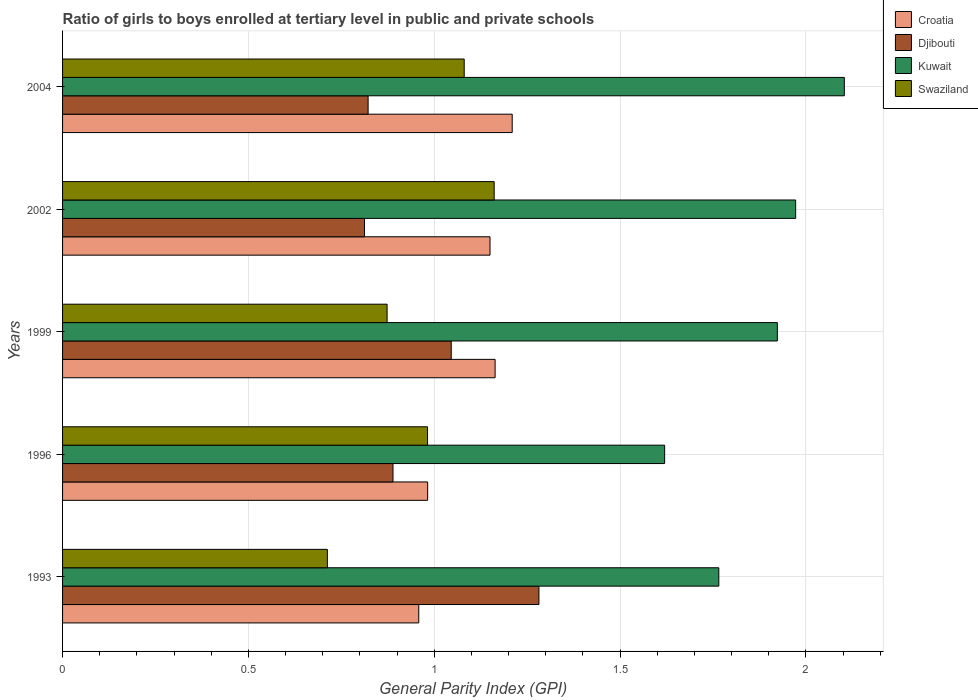Are the number of bars per tick equal to the number of legend labels?
Your answer should be compact. Yes. Are the number of bars on each tick of the Y-axis equal?
Your answer should be compact. Yes. What is the label of the 1st group of bars from the top?
Your answer should be very brief. 2004. What is the general parity index in Swaziland in 2002?
Ensure brevity in your answer.  1.16. Across all years, what is the maximum general parity index in Kuwait?
Give a very brief answer. 2.1. Across all years, what is the minimum general parity index in Croatia?
Offer a very short reply. 0.96. What is the total general parity index in Swaziland in the graph?
Provide a short and direct response. 4.81. What is the difference between the general parity index in Kuwait in 1999 and that in 2002?
Your response must be concise. -0.05. What is the difference between the general parity index in Djibouti in 1993 and the general parity index in Swaziland in 2002?
Make the answer very short. 0.12. What is the average general parity index in Djibouti per year?
Provide a short and direct response. 0.97. In the year 2002, what is the difference between the general parity index in Kuwait and general parity index in Swaziland?
Give a very brief answer. 0.81. In how many years, is the general parity index in Kuwait greater than 1.7 ?
Give a very brief answer. 4. What is the ratio of the general parity index in Kuwait in 1993 to that in 1996?
Provide a succinct answer. 1.09. What is the difference between the highest and the second highest general parity index in Djibouti?
Ensure brevity in your answer.  0.24. What is the difference between the highest and the lowest general parity index in Swaziland?
Make the answer very short. 0.45. Is the sum of the general parity index in Kuwait in 1993 and 1996 greater than the maximum general parity index in Djibouti across all years?
Keep it short and to the point. Yes. Is it the case that in every year, the sum of the general parity index in Croatia and general parity index in Kuwait is greater than the sum of general parity index in Swaziland and general parity index in Djibouti?
Give a very brief answer. Yes. What does the 4th bar from the top in 1996 represents?
Your answer should be very brief. Croatia. What does the 2nd bar from the bottom in 1993 represents?
Offer a very short reply. Djibouti. Are all the bars in the graph horizontal?
Make the answer very short. Yes. What is the difference between two consecutive major ticks on the X-axis?
Give a very brief answer. 0.5. Does the graph contain any zero values?
Offer a very short reply. No. How many legend labels are there?
Provide a succinct answer. 4. How are the legend labels stacked?
Offer a very short reply. Vertical. What is the title of the graph?
Your answer should be compact. Ratio of girls to boys enrolled at tertiary level in public and private schools. What is the label or title of the X-axis?
Your answer should be compact. General Parity Index (GPI). What is the General Parity Index (GPI) of Croatia in 1993?
Offer a very short reply. 0.96. What is the General Parity Index (GPI) in Djibouti in 1993?
Make the answer very short. 1.28. What is the General Parity Index (GPI) of Kuwait in 1993?
Ensure brevity in your answer.  1.77. What is the General Parity Index (GPI) of Swaziland in 1993?
Ensure brevity in your answer.  0.71. What is the General Parity Index (GPI) in Croatia in 1996?
Make the answer very short. 0.98. What is the General Parity Index (GPI) in Djibouti in 1996?
Make the answer very short. 0.89. What is the General Parity Index (GPI) of Kuwait in 1996?
Offer a very short reply. 1.62. What is the General Parity Index (GPI) of Swaziland in 1996?
Offer a terse response. 0.98. What is the General Parity Index (GPI) in Croatia in 1999?
Offer a very short reply. 1.16. What is the General Parity Index (GPI) of Djibouti in 1999?
Give a very brief answer. 1.05. What is the General Parity Index (GPI) in Kuwait in 1999?
Your response must be concise. 1.92. What is the General Parity Index (GPI) of Swaziland in 1999?
Your answer should be very brief. 0.87. What is the General Parity Index (GPI) in Croatia in 2002?
Your response must be concise. 1.15. What is the General Parity Index (GPI) in Djibouti in 2002?
Offer a very short reply. 0.81. What is the General Parity Index (GPI) in Kuwait in 2002?
Your response must be concise. 1.97. What is the General Parity Index (GPI) of Swaziland in 2002?
Ensure brevity in your answer.  1.16. What is the General Parity Index (GPI) in Croatia in 2004?
Offer a very short reply. 1.21. What is the General Parity Index (GPI) of Djibouti in 2004?
Make the answer very short. 0.82. What is the General Parity Index (GPI) in Kuwait in 2004?
Provide a short and direct response. 2.1. What is the General Parity Index (GPI) of Swaziland in 2004?
Make the answer very short. 1.08. Across all years, what is the maximum General Parity Index (GPI) of Croatia?
Your answer should be very brief. 1.21. Across all years, what is the maximum General Parity Index (GPI) in Djibouti?
Your answer should be very brief. 1.28. Across all years, what is the maximum General Parity Index (GPI) of Kuwait?
Your answer should be very brief. 2.1. Across all years, what is the maximum General Parity Index (GPI) of Swaziland?
Make the answer very short. 1.16. Across all years, what is the minimum General Parity Index (GPI) in Croatia?
Your answer should be very brief. 0.96. Across all years, what is the minimum General Parity Index (GPI) in Djibouti?
Your answer should be compact. 0.81. Across all years, what is the minimum General Parity Index (GPI) in Kuwait?
Your answer should be very brief. 1.62. Across all years, what is the minimum General Parity Index (GPI) in Swaziland?
Your answer should be very brief. 0.71. What is the total General Parity Index (GPI) of Croatia in the graph?
Make the answer very short. 5.46. What is the total General Parity Index (GPI) of Djibouti in the graph?
Keep it short and to the point. 4.85. What is the total General Parity Index (GPI) of Kuwait in the graph?
Your answer should be compact. 9.38. What is the total General Parity Index (GPI) of Swaziland in the graph?
Give a very brief answer. 4.81. What is the difference between the General Parity Index (GPI) of Croatia in 1993 and that in 1996?
Your answer should be compact. -0.02. What is the difference between the General Parity Index (GPI) in Djibouti in 1993 and that in 1996?
Ensure brevity in your answer.  0.39. What is the difference between the General Parity Index (GPI) of Kuwait in 1993 and that in 1996?
Provide a succinct answer. 0.15. What is the difference between the General Parity Index (GPI) of Swaziland in 1993 and that in 1996?
Ensure brevity in your answer.  -0.27. What is the difference between the General Parity Index (GPI) of Croatia in 1993 and that in 1999?
Keep it short and to the point. -0.21. What is the difference between the General Parity Index (GPI) of Djibouti in 1993 and that in 1999?
Give a very brief answer. 0.24. What is the difference between the General Parity Index (GPI) of Kuwait in 1993 and that in 1999?
Your answer should be very brief. -0.16. What is the difference between the General Parity Index (GPI) in Swaziland in 1993 and that in 1999?
Your answer should be very brief. -0.16. What is the difference between the General Parity Index (GPI) of Croatia in 1993 and that in 2002?
Provide a succinct answer. -0.19. What is the difference between the General Parity Index (GPI) in Djibouti in 1993 and that in 2002?
Ensure brevity in your answer.  0.47. What is the difference between the General Parity Index (GPI) in Kuwait in 1993 and that in 2002?
Provide a succinct answer. -0.21. What is the difference between the General Parity Index (GPI) in Swaziland in 1993 and that in 2002?
Provide a short and direct response. -0.45. What is the difference between the General Parity Index (GPI) of Croatia in 1993 and that in 2004?
Your answer should be compact. -0.25. What is the difference between the General Parity Index (GPI) of Djibouti in 1993 and that in 2004?
Your answer should be very brief. 0.46. What is the difference between the General Parity Index (GPI) in Kuwait in 1993 and that in 2004?
Make the answer very short. -0.34. What is the difference between the General Parity Index (GPI) of Swaziland in 1993 and that in 2004?
Make the answer very short. -0.37. What is the difference between the General Parity Index (GPI) of Croatia in 1996 and that in 1999?
Make the answer very short. -0.18. What is the difference between the General Parity Index (GPI) in Djibouti in 1996 and that in 1999?
Offer a very short reply. -0.16. What is the difference between the General Parity Index (GPI) of Kuwait in 1996 and that in 1999?
Your answer should be very brief. -0.3. What is the difference between the General Parity Index (GPI) of Swaziland in 1996 and that in 1999?
Offer a terse response. 0.11. What is the difference between the General Parity Index (GPI) in Croatia in 1996 and that in 2002?
Your answer should be compact. -0.17. What is the difference between the General Parity Index (GPI) in Djibouti in 1996 and that in 2002?
Your response must be concise. 0.08. What is the difference between the General Parity Index (GPI) in Kuwait in 1996 and that in 2002?
Offer a terse response. -0.35. What is the difference between the General Parity Index (GPI) in Swaziland in 1996 and that in 2002?
Your answer should be very brief. -0.18. What is the difference between the General Parity Index (GPI) of Croatia in 1996 and that in 2004?
Keep it short and to the point. -0.23. What is the difference between the General Parity Index (GPI) of Djibouti in 1996 and that in 2004?
Offer a very short reply. 0.07. What is the difference between the General Parity Index (GPI) in Kuwait in 1996 and that in 2004?
Keep it short and to the point. -0.48. What is the difference between the General Parity Index (GPI) in Swaziland in 1996 and that in 2004?
Provide a short and direct response. -0.1. What is the difference between the General Parity Index (GPI) of Croatia in 1999 and that in 2002?
Your answer should be compact. 0.01. What is the difference between the General Parity Index (GPI) in Djibouti in 1999 and that in 2002?
Provide a succinct answer. 0.23. What is the difference between the General Parity Index (GPI) of Kuwait in 1999 and that in 2002?
Your answer should be very brief. -0.05. What is the difference between the General Parity Index (GPI) in Swaziland in 1999 and that in 2002?
Provide a succinct answer. -0.29. What is the difference between the General Parity Index (GPI) in Croatia in 1999 and that in 2004?
Give a very brief answer. -0.05. What is the difference between the General Parity Index (GPI) of Djibouti in 1999 and that in 2004?
Your response must be concise. 0.22. What is the difference between the General Parity Index (GPI) of Kuwait in 1999 and that in 2004?
Your response must be concise. -0.18. What is the difference between the General Parity Index (GPI) in Swaziland in 1999 and that in 2004?
Provide a succinct answer. -0.21. What is the difference between the General Parity Index (GPI) of Croatia in 2002 and that in 2004?
Offer a very short reply. -0.06. What is the difference between the General Parity Index (GPI) in Djibouti in 2002 and that in 2004?
Keep it short and to the point. -0.01. What is the difference between the General Parity Index (GPI) in Kuwait in 2002 and that in 2004?
Make the answer very short. -0.13. What is the difference between the General Parity Index (GPI) of Swaziland in 2002 and that in 2004?
Provide a short and direct response. 0.08. What is the difference between the General Parity Index (GPI) in Croatia in 1993 and the General Parity Index (GPI) in Djibouti in 1996?
Keep it short and to the point. 0.07. What is the difference between the General Parity Index (GPI) in Croatia in 1993 and the General Parity Index (GPI) in Kuwait in 1996?
Your answer should be compact. -0.66. What is the difference between the General Parity Index (GPI) of Croatia in 1993 and the General Parity Index (GPI) of Swaziland in 1996?
Your answer should be very brief. -0.02. What is the difference between the General Parity Index (GPI) in Djibouti in 1993 and the General Parity Index (GPI) in Kuwait in 1996?
Offer a terse response. -0.34. What is the difference between the General Parity Index (GPI) in Djibouti in 1993 and the General Parity Index (GPI) in Swaziland in 1996?
Offer a very short reply. 0.3. What is the difference between the General Parity Index (GPI) of Kuwait in 1993 and the General Parity Index (GPI) of Swaziland in 1996?
Ensure brevity in your answer.  0.78. What is the difference between the General Parity Index (GPI) in Croatia in 1993 and the General Parity Index (GPI) in Djibouti in 1999?
Offer a terse response. -0.09. What is the difference between the General Parity Index (GPI) in Croatia in 1993 and the General Parity Index (GPI) in Kuwait in 1999?
Your answer should be very brief. -0.96. What is the difference between the General Parity Index (GPI) in Croatia in 1993 and the General Parity Index (GPI) in Swaziland in 1999?
Ensure brevity in your answer.  0.09. What is the difference between the General Parity Index (GPI) of Djibouti in 1993 and the General Parity Index (GPI) of Kuwait in 1999?
Your response must be concise. -0.64. What is the difference between the General Parity Index (GPI) in Djibouti in 1993 and the General Parity Index (GPI) in Swaziland in 1999?
Provide a succinct answer. 0.41. What is the difference between the General Parity Index (GPI) of Kuwait in 1993 and the General Parity Index (GPI) of Swaziland in 1999?
Offer a terse response. 0.89. What is the difference between the General Parity Index (GPI) of Croatia in 1993 and the General Parity Index (GPI) of Djibouti in 2002?
Make the answer very short. 0.15. What is the difference between the General Parity Index (GPI) in Croatia in 1993 and the General Parity Index (GPI) in Kuwait in 2002?
Offer a terse response. -1.01. What is the difference between the General Parity Index (GPI) in Croatia in 1993 and the General Parity Index (GPI) in Swaziland in 2002?
Provide a short and direct response. -0.2. What is the difference between the General Parity Index (GPI) in Djibouti in 1993 and the General Parity Index (GPI) in Kuwait in 2002?
Offer a terse response. -0.69. What is the difference between the General Parity Index (GPI) in Djibouti in 1993 and the General Parity Index (GPI) in Swaziland in 2002?
Your answer should be very brief. 0.12. What is the difference between the General Parity Index (GPI) of Kuwait in 1993 and the General Parity Index (GPI) of Swaziland in 2002?
Give a very brief answer. 0.6. What is the difference between the General Parity Index (GPI) of Croatia in 1993 and the General Parity Index (GPI) of Djibouti in 2004?
Make the answer very short. 0.14. What is the difference between the General Parity Index (GPI) of Croatia in 1993 and the General Parity Index (GPI) of Kuwait in 2004?
Offer a terse response. -1.15. What is the difference between the General Parity Index (GPI) in Croatia in 1993 and the General Parity Index (GPI) in Swaziland in 2004?
Offer a terse response. -0.12. What is the difference between the General Parity Index (GPI) of Djibouti in 1993 and the General Parity Index (GPI) of Kuwait in 2004?
Offer a very short reply. -0.82. What is the difference between the General Parity Index (GPI) in Djibouti in 1993 and the General Parity Index (GPI) in Swaziland in 2004?
Provide a succinct answer. 0.2. What is the difference between the General Parity Index (GPI) of Kuwait in 1993 and the General Parity Index (GPI) of Swaziland in 2004?
Your answer should be compact. 0.69. What is the difference between the General Parity Index (GPI) in Croatia in 1996 and the General Parity Index (GPI) in Djibouti in 1999?
Offer a terse response. -0.06. What is the difference between the General Parity Index (GPI) of Croatia in 1996 and the General Parity Index (GPI) of Kuwait in 1999?
Your answer should be very brief. -0.94. What is the difference between the General Parity Index (GPI) of Croatia in 1996 and the General Parity Index (GPI) of Swaziland in 1999?
Ensure brevity in your answer.  0.11. What is the difference between the General Parity Index (GPI) of Djibouti in 1996 and the General Parity Index (GPI) of Kuwait in 1999?
Your answer should be compact. -1.03. What is the difference between the General Parity Index (GPI) of Djibouti in 1996 and the General Parity Index (GPI) of Swaziland in 1999?
Provide a succinct answer. 0.02. What is the difference between the General Parity Index (GPI) in Kuwait in 1996 and the General Parity Index (GPI) in Swaziland in 1999?
Your response must be concise. 0.75. What is the difference between the General Parity Index (GPI) of Croatia in 1996 and the General Parity Index (GPI) of Djibouti in 2002?
Offer a terse response. 0.17. What is the difference between the General Parity Index (GPI) of Croatia in 1996 and the General Parity Index (GPI) of Kuwait in 2002?
Ensure brevity in your answer.  -0.99. What is the difference between the General Parity Index (GPI) of Croatia in 1996 and the General Parity Index (GPI) of Swaziland in 2002?
Provide a succinct answer. -0.18. What is the difference between the General Parity Index (GPI) in Djibouti in 1996 and the General Parity Index (GPI) in Kuwait in 2002?
Your answer should be very brief. -1.08. What is the difference between the General Parity Index (GPI) of Djibouti in 1996 and the General Parity Index (GPI) of Swaziland in 2002?
Your answer should be compact. -0.27. What is the difference between the General Parity Index (GPI) of Kuwait in 1996 and the General Parity Index (GPI) of Swaziland in 2002?
Your answer should be very brief. 0.46. What is the difference between the General Parity Index (GPI) in Croatia in 1996 and the General Parity Index (GPI) in Djibouti in 2004?
Provide a short and direct response. 0.16. What is the difference between the General Parity Index (GPI) in Croatia in 1996 and the General Parity Index (GPI) in Kuwait in 2004?
Your response must be concise. -1.12. What is the difference between the General Parity Index (GPI) of Croatia in 1996 and the General Parity Index (GPI) of Swaziland in 2004?
Your response must be concise. -0.1. What is the difference between the General Parity Index (GPI) of Djibouti in 1996 and the General Parity Index (GPI) of Kuwait in 2004?
Your response must be concise. -1.21. What is the difference between the General Parity Index (GPI) in Djibouti in 1996 and the General Parity Index (GPI) in Swaziland in 2004?
Offer a terse response. -0.19. What is the difference between the General Parity Index (GPI) of Kuwait in 1996 and the General Parity Index (GPI) of Swaziland in 2004?
Offer a very short reply. 0.54. What is the difference between the General Parity Index (GPI) in Croatia in 1999 and the General Parity Index (GPI) in Djibouti in 2002?
Ensure brevity in your answer.  0.35. What is the difference between the General Parity Index (GPI) of Croatia in 1999 and the General Parity Index (GPI) of Kuwait in 2002?
Your answer should be very brief. -0.81. What is the difference between the General Parity Index (GPI) of Croatia in 1999 and the General Parity Index (GPI) of Swaziland in 2002?
Provide a short and direct response. 0. What is the difference between the General Parity Index (GPI) of Djibouti in 1999 and the General Parity Index (GPI) of Kuwait in 2002?
Keep it short and to the point. -0.93. What is the difference between the General Parity Index (GPI) of Djibouti in 1999 and the General Parity Index (GPI) of Swaziland in 2002?
Your answer should be compact. -0.12. What is the difference between the General Parity Index (GPI) of Kuwait in 1999 and the General Parity Index (GPI) of Swaziland in 2002?
Give a very brief answer. 0.76. What is the difference between the General Parity Index (GPI) in Croatia in 1999 and the General Parity Index (GPI) in Djibouti in 2004?
Provide a succinct answer. 0.34. What is the difference between the General Parity Index (GPI) in Croatia in 1999 and the General Parity Index (GPI) in Kuwait in 2004?
Your response must be concise. -0.94. What is the difference between the General Parity Index (GPI) of Croatia in 1999 and the General Parity Index (GPI) of Swaziland in 2004?
Provide a succinct answer. 0.08. What is the difference between the General Parity Index (GPI) of Djibouti in 1999 and the General Parity Index (GPI) of Kuwait in 2004?
Make the answer very short. -1.06. What is the difference between the General Parity Index (GPI) in Djibouti in 1999 and the General Parity Index (GPI) in Swaziland in 2004?
Provide a short and direct response. -0.03. What is the difference between the General Parity Index (GPI) of Kuwait in 1999 and the General Parity Index (GPI) of Swaziland in 2004?
Offer a very short reply. 0.84. What is the difference between the General Parity Index (GPI) in Croatia in 2002 and the General Parity Index (GPI) in Djibouti in 2004?
Your answer should be very brief. 0.33. What is the difference between the General Parity Index (GPI) in Croatia in 2002 and the General Parity Index (GPI) in Kuwait in 2004?
Provide a short and direct response. -0.95. What is the difference between the General Parity Index (GPI) of Croatia in 2002 and the General Parity Index (GPI) of Swaziland in 2004?
Your response must be concise. 0.07. What is the difference between the General Parity Index (GPI) in Djibouti in 2002 and the General Parity Index (GPI) in Kuwait in 2004?
Provide a succinct answer. -1.29. What is the difference between the General Parity Index (GPI) of Djibouti in 2002 and the General Parity Index (GPI) of Swaziland in 2004?
Make the answer very short. -0.27. What is the difference between the General Parity Index (GPI) in Kuwait in 2002 and the General Parity Index (GPI) in Swaziland in 2004?
Keep it short and to the point. 0.89. What is the average General Parity Index (GPI) in Croatia per year?
Make the answer very short. 1.09. What is the average General Parity Index (GPI) of Djibouti per year?
Offer a very short reply. 0.97. What is the average General Parity Index (GPI) of Kuwait per year?
Give a very brief answer. 1.88. What is the average General Parity Index (GPI) of Swaziland per year?
Give a very brief answer. 0.96. In the year 1993, what is the difference between the General Parity Index (GPI) of Croatia and General Parity Index (GPI) of Djibouti?
Your response must be concise. -0.32. In the year 1993, what is the difference between the General Parity Index (GPI) of Croatia and General Parity Index (GPI) of Kuwait?
Offer a terse response. -0.81. In the year 1993, what is the difference between the General Parity Index (GPI) of Croatia and General Parity Index (GPI) of Swaziland?
Offer a terse response. 0.25. In the year 1993, what is the difference between the General Parity Index (GPI) of Djibouti and General Parity Index (GPI) of Kuwait?
Keep it short and to the point. -0.48. In the year 1993, what is the difference between the General Parity Index (GPI) of Djibouti and General Parity Index (GPI) of Swaziland?
Offer a terse response. 0.57. In the year 1993, what is the difference between the General Parity Index (GPI) of Kuwait and General Parity Index (GPI) of Swaziland?
Offer a terse response. 1.05. In the year 1996, what is the difference between the General Parity Index (GPI) in Croatia and General Parity Index (GPI) in Djibouti?
Make the answer very short. 0.09. In the year 1996, what is the difference between the General Parity Index (GPI) of Croatia and General Parity Index (GPI) of Kuwait?
Offer a very short reply. -0.64. In the year 1996, what is the difference between the General Parity Index (GPI) of Djibouti and General Parity Index (GPI) of Kuwait?
Offer a terse response. -0.73. In the year 1996, what is the difference between the General Parity Index (GPI) of Djibouti and General Parity Index (GPI) of Swaziland?
Ensure brevity in your answer.  -0.09. In the year 1996, what is the difference between the General Parity Index (GPI) of Kuwait and General Parity Index (GPI) of Swaziland?
Give a very brief answer. 0.64. In the year 1999, what is the difference between the General Parity Index (GPI) of Croatia and General Parity Index (GPI) of Djibouti?
Keep it short and to the point. 0.12. In the year 1999, what is the difference between the General Parity Index (GPI) in Croatia and General Parity Index (GPI) in Kuwait?
Give a very brief answer. -0.76. In the year 1999, what is the difference between the General Parity Index (GPI) of Croatia and General Parity Index (GPI) of Swaziland?
Ensure brevity in your answer.  0.29. In the year 1999, what is the difference between the General Parity Index (GPI) in Djibouti and General Parity Index (GPI) in Kuwait?
Your response must be concise. -0.88. In the year 1999, what is the difference between the General Parity Index (GPI) in Djibouti and General Parity Index (GPI) in Swaziland?
Keep it short and to the point. 0.17. In the year 1999, what is the difference between the General Parity Index (GPI) in Kuwait and General Parity Index (GPI) in Swaziland?
Your response must be concise. 1.05. In the year 2002, what is the difference between the General Parity Index (GPI) of Croatia and General Parity Index (GPI) of Djibouti?
Your answer should be compact. 0.34. In the year 2002, what is the difference between the General Parity Index (GPI) in Croatia and General Parity Index (GPI) in Kuwait?
Your answer should be very brief. -0.82. In the year 2002, what is the difference between the General Parity Index (GPI) in Croatia and General Parity Index (GPI) in Swaziland?
Keep it short and to the point. -0.01. In the year 2002, what is the difference between the General Parity Index (GPI) in Djibouti and General Parity Index (GPI) in Kuwait?
Your response must be concise. -1.16. In the year 2002, what is the difference between the General Parity Index (GPI) in Djibouti and General Parity Index (GPI) in Swaziland?
Provide a short and direct response. -0.35. In the year 2002, what is the difference between the General Parity Index (GPI) of Kuwait and General Parity Index (GPI) of Swaziland?
Provide a short and direct response. 0.81. In the year 2004, what is the difference between the General Parity Index (GPI) of Croatia and General Parity Index (GPI) of Djibouti?
Your response must be concise. 0.39. In the year 2004, what is the difference between the General Parity Index (GPI) in Croatia and General Parity Index (GPI) in Kuwait?
Your response must be concise. -0.89. In the year 2004, what is the difference between the General Parity Index (GPI) of Croatia and General Parity Index (GPI) of Swaziland?
Your answer should be compact. 0.13. In the year 2004, what is the difference between the General Parity Index (GPI) of Djibouti and General Parity Index (GPI) of Kuwait?
Provide a succinct answer. -1.28. In the year 2004, what is the difference between the General Parity Index (GPI) in Djibouti and General Parity Index (GPI) in Swaziland?
Give a very brief answer. -0.26. In the year 2004, what is the difference between the General Parity Index (GPI) in Kuwait and General Parity Index (GPI) in Swaziland?
Your answer should be very brief. 1.02. What is the ratio of the General Parity Index (GPI) in Croatia in 1993 to that in 1996?
Offer a very short reply. 0.98. What is the ratio of the General Parity Index (GPI) of Djibouti in 1993 to that in 1996?
Provide a succinct answer. 1.44. What is the ratio of the General Parity Index (GPI) of Kuwait in 1993 to that in 1996?
Ensure brevity in your answer.  1.09. What is the ratio of the General Parity Index (GPI) in Swaziland in 1993 to that in 1996?
Offer a terse response. 0.73. What is the ratio of the General Parity Index (GPI) of Croatia in 1993 to that in 1999?
Provide a succinct answer. 0.82. What is the ratio of the General Parity Index (GPI) in Djibouti in 1993 to that in 1999?
Provide a short and direct response. 1.23. What is the ratio of the General Parity Index (GPI) in Kuwait in 1993 to that in 1999?
Offer a terse response. 0.92. What is the ratio of the General Parity Index (GPI) in Swaziland in 1993 to that in 1999?
Provide a succinct answer. 0.82. What is the ratio of the General Parity Index (GPI) in Croatia in 1993 to that in 2002?
Offer a very short reply. 0.83. What is the ratio of the General Parity Index (GPI) of Djibouti in 1993 to that in 2002?
Provide a short and direct response. 1.58. What is the ratio of the General Parity Index (GPI) in Kuwait in 1993 to that in 2002?
Your answer should be very brief. 0.9. What is the ratio of the General Parity Index (GPI) in Swaziland in 1993 to that in 2002?
Give a very brief answer. 0.61. What is the ratio of the General Parity Index (GPI) in Croatia in 1993 to that in 2004?
Your response must be concise. 0.79. What is the ratio of the General Parity Index (GPI) in Djibouti in 1993 to that in 2004?
Make the answer very short. 1.56. What is the ratio of the General Parity Index (GPI) in Kuwait in 1993 to that in 2004?
Provide a short and direct response. 0.84. What is the ratio of the General Parity Index (GPI) in Swaziland in 1993 to that in 2004?
Ensure brevity in your answer.  0.66. What is the ratio of the General Parity Index (GPI) in Croatia in 1996 to that in 1999?
Your answer should be very brief. 0.84. What is the ratio of the General Parity Index (GPI) in Djibouti in 1996 to that in 1999?
Offer a terse response. 0.85. What is the ratio of the General Parity Index (GPI) of Kuwait in 1996 to that in 1999?
Your answer should be compact. 0.84. What is the ratio of the General Parity Index (GPI) in Swaziland in 1996 to that in 1999?
Offer a very short reply. 1.12. What is the ratio of the General Parity Index (GPI) in Croatia in 1996 to that in 2002?
Provide a succinct answer. 0.85. What is the ratio of the General Parity Index (GPI) in Djibouti in 1996 to that in 2002?
Your response must be concise. 1.09. What is the ratio of the General Parity Index (GPI) in Kuwait in 1996 to that in 2002?
Ensure brevity in your answer.  0.82. What is the ratio of the General Parity Index (GPI) in Swaziland in 1996 to that in 2002?
Offer a very short reply. 0.85. What is the ratio of the General Parity Index (GPI) of Croatia in 1996 to that in 2004?
Offer a very short reply. 0.81. What is the ratio of the General Parity Index (GPI) of Djibouti in 1996 to that in 2004?
Offer a very short reply. 1.08. What is the ratio of the General Parity Index (GPI) in Kuwait in 1996 to that in 2004?
Provide a succinct answer. 0.77. What is the ratio of the General Parity Index (GPI) in Swaziland in 1996 to that in 2004?
Your response must be concise. 0.91. What is the ratio of the General Parity Index (GPI) in Croatia in 1999 to that in 2002?
Ensure brevity in your answer.  1.01. What is the ratio of the General Parity Index (GPI) of Djibouti in 1999 to that in 2002?
Your response must be concise. 1.29. What is the ratio of the General Parity Index (GPI) of Swaziland in 1999 to that in 2002?
Make the answer very short. 0.75. What is the ratio of the General Parity Index (GPI) of Djibouti in 1999 to that in 2004?
Make the answer very short. 1.27. What is the ratio of the General Parity Index (GPI) of Kuwait in 1999 to that in 2004?
Provide a succinct answer. 0.91. What is the ratio of the General Parity Index (GPI) in Swaziland in 1999 to that in 2004?
Your response must be concise. 0.81. What is the ratio of the General Parity Index (GPI) of Croatia in 2002 to that in 2004?
Provide a short and direct response. 0.95. What is the ratio of the General Parity Index (GPI) in Kuwait in 2002 to that in 2004?
Give a very brief answer. 0.94. What is the ratio of the General Parity Index (GPI) of Swaziland in 2002 to that in 2004?
Your answer should be compact. 1.07. What is the difference between the highest and the second highest General Parity Index (GPI) in Croatia?
Offer a very short reply. 0.05. What is the difference between the highest and the second highest General Parity Index (GPI) of Djibouti?
Your answer should be compact. 0.24. What is the difference between the highest and the second highest General Parity Index (GPI) of Kuwait?
Offer a terse response. 0.13. What is the difference between the highest and the second highest General Parity Index (GPI) in Swaziland?
Make the answer very short. 0.08. What is the difference between the highest and the lowest General Parity Index (GPI) of Croatia?
Make the answer very short. 0.25. What is the difference between the highest and the lowest General Parity Index (GPI) in Djibouti?
Your answer should be very brief. 0.47. What is the difference between the highest and the lowest General Parity Index (GPI) of Kuwait?
Your answer should be very brief. 0.48. What is the difference between the highest and the lowest General Parity Index (GPI) in Swaziland?
Your response must be concise. 0.45. 